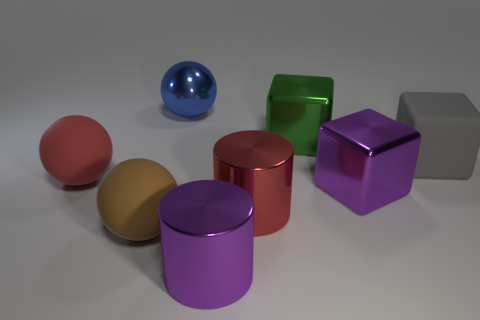How many other objects are there of the same size as the red matte sphere?
Make the answer very short. 7. Is there anything else that has the same shape as the large red rubber thing?
Make the answer very short. Yes. Are there the same number of big red rubber balls on the left side of the purple metal cylinder and large red rubber balls?
Your response must be concise. Yes. How many things are the same material as the purple block?
Your response must be concise. 4. The ball that is made of the same material as the purple cylinder is what color?
Ensure brevity in your answer.  Blue. Does the red rubber object have the same shape as the brown matte object?
Your response must be concise. Yes. There is a large brown matte sphere that is in front of the big metallic cube in front of the red matte sphere; is there a cube that is left of it?
Offer a very short reply. No. How many rubber things have the same color as the metal ball?
Provide a short and direct response. 0. What shape is the red rubber thing that is the same size as the blue ball?
Ensure brevity in your answer.  Sphere. Are there any large cylinders on the right side of the large red metallic cylinder?
Give a very brief answer. No. 